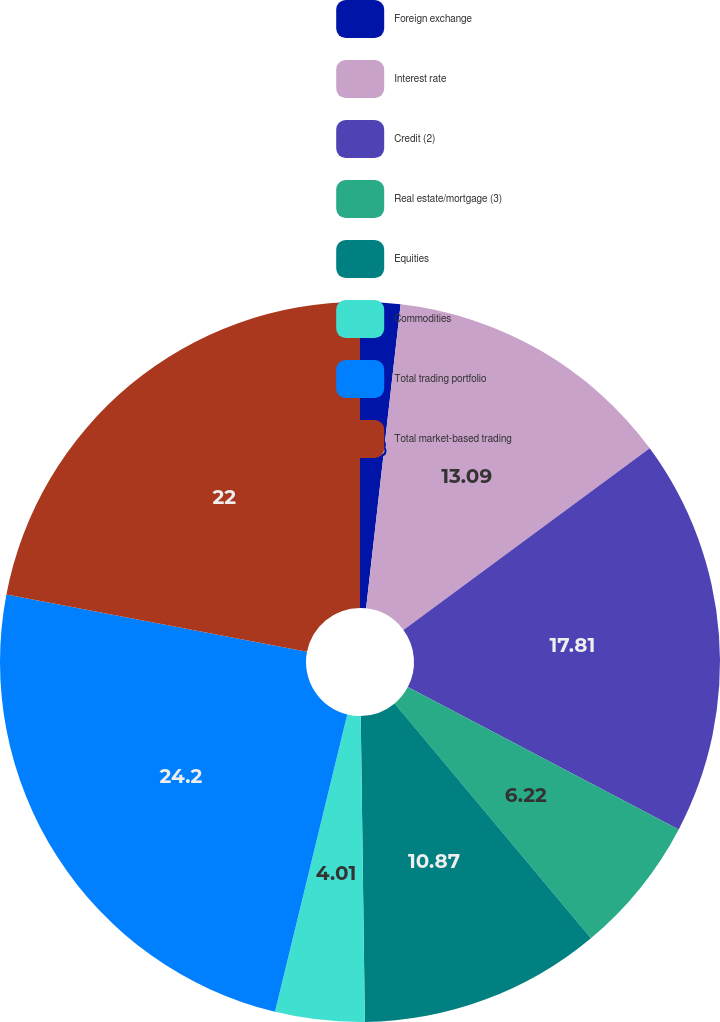Convert chart. <chart><loc_0><loc_0><loc_500><loc_500><pie_chart><fcel>Foreign exchange<fcel>Interest rate<fcel>Credit (2)<fcel>Real estate/mortgage (3)<fcel>Equities<fcel>Commodities<fcel>Total trading portfolio<fcel>Total market-based trading<nl><fcel>1.8%<fcel>13.09%<fcel>17.81%<fcel>6.22%<fcel>10.87%<fcel>4.01%<fcel>24.21%<fcel>22.0%<nl></chart> 